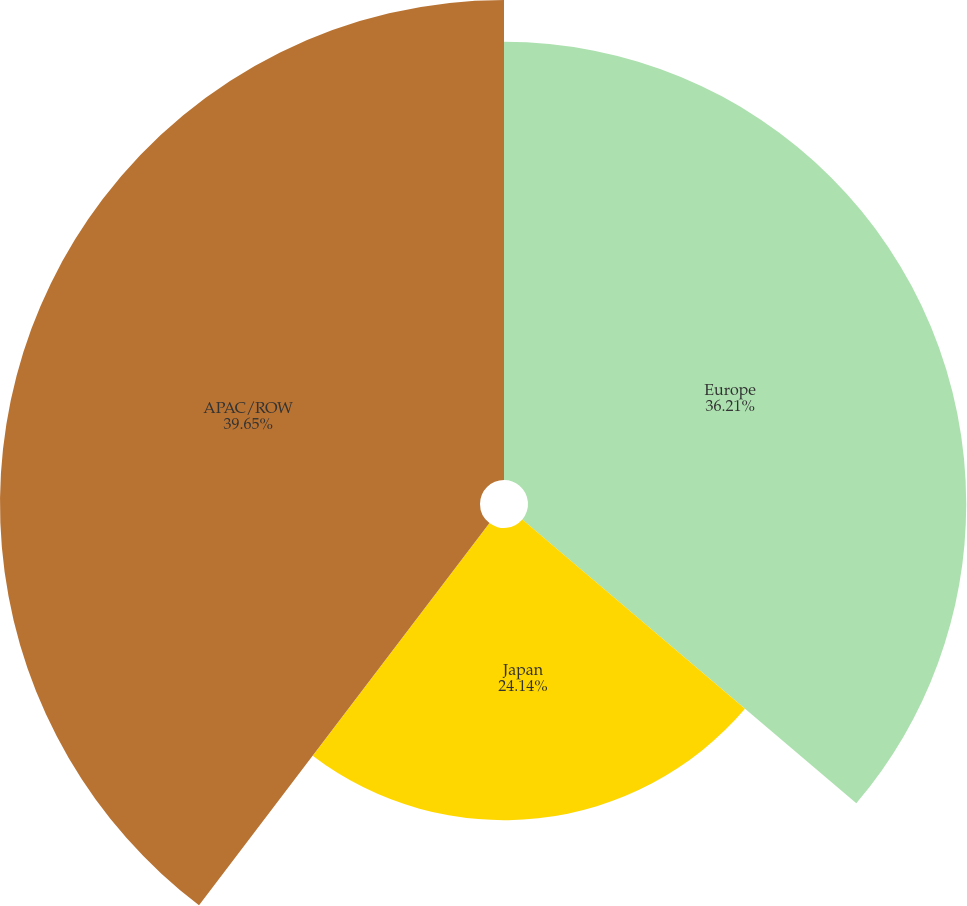Convert chart to OTSL. <chart><loc_0><loc_0><loc_500><loc_500><pie_chart><fcel>Europe<fcel>Japan<fcel>APAC/ROW<nl><fcel>36.21%<fcel>24.14%<fcel>39.66%<nl></chart> 